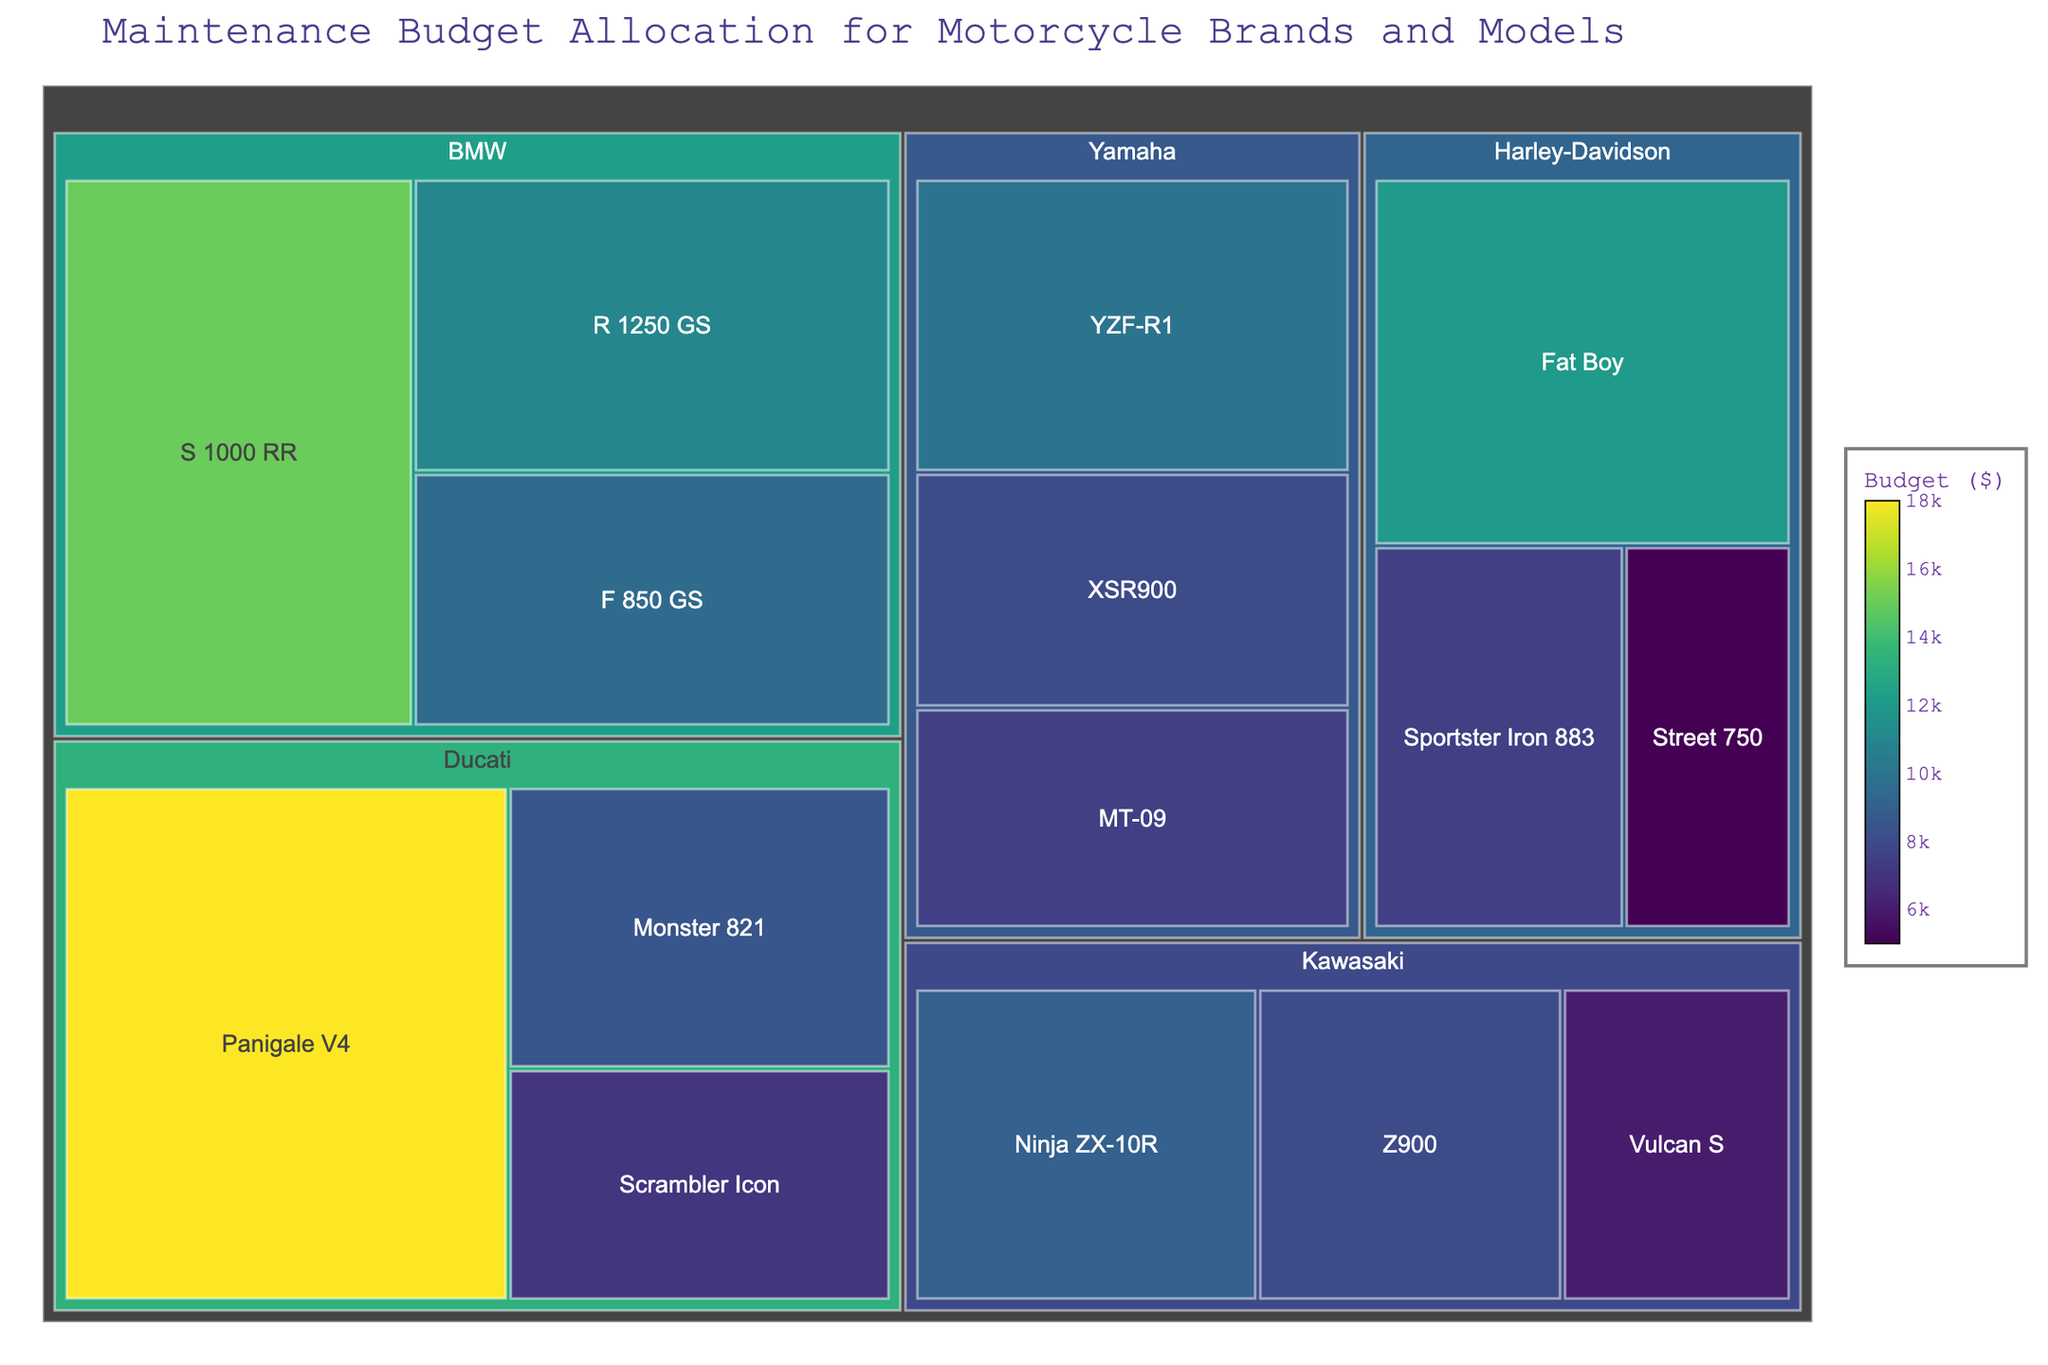What is the title of the treemap? The title is displayed at the top of the treemap figure and gives an overview of the data being presented.
Answer: Maintenance Budget Allocation for Motorcycle Brands and Models Which motorcycle brand has the largest maintenance budget allocation? By looking at the largest segment in the treemap, we can see that Ducati has the largest budget allocation due to the high-value segments.
Answer: Ducati What is the budget for the Harley-Davidson Fat Boy model? Locate the Harley-Davidson brand first and identify the segment labeled "Fat Boy" to see the budget value displayed within the segment.
Answer: $12,000 How many models are represented for the Yamaha brand? Observe the number of smaller segments within the larger Yamaha segment in the treemap.
Answer: 3 Which brand has the smallest maintenance budget allocation? Compare the smallest segment sizes among the brands in the treemap; the one that occupies the least space is the answer.
Answer: BMW What is the total maintenance budget for Kawasaki motorcycles? Sum the individual budget values for all Kawasaki models: Ninja ZX-10R ($9,000), Vulcan S ($6,000), Z900 ($8,000). The total is $9,000 + $6,000 + $8,000.
Answer: $23,000 Between the Ducati Panigale V4 and BMW S 1000 RR, which model has a higher maintenance budget? Locate both Ducati Panigale V4 and BMW S 1000 RR in the treemap and compare their budget values.
Answer: Ducati Panigale V4 What is the average budget allocation for Yamaha models? Sum the budget values for all Yamaha models: YZF-R1 ($10,000), MT-09 ($7,500), XSR900 ($8,000) and divide by the number of models (3). The total is $10,000 + $7,500 + $8,000 = $25,500. The average is $25,500 / 3.
Answer: $8,500 Which Harley-Davidson model has the lowest maintenance budget allocation? Among the Harley-Davidson segments, find which one has the smallest budget value.
Answer: Street 750 What is the combined budget for all Ducati models? Add up the budget values for Ducati Panigale V4 ($18,000), Monster 821 ($8,500), and Scrambler Icon ($7,000). The total is $18,000 + $8,500 + $7,000.
Answer: $33,500 